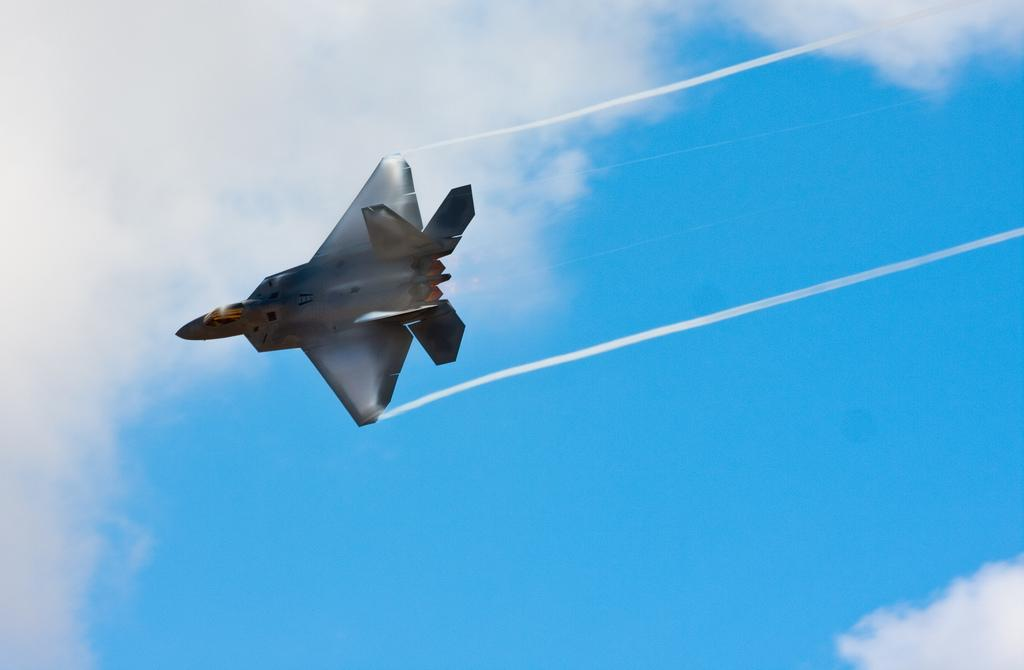What is the main subject of the image? The main subject of the image is a Jet plane. What can be seen in the background of the image? The sky is visible in the background of the image. How many flowers are present in the image? There are no flowers present in the image; it features a Jet plane and the sky. What emotion does the Jet plane express in the image? The Jet plane is an inanimate object and does not express emotions like fear. 